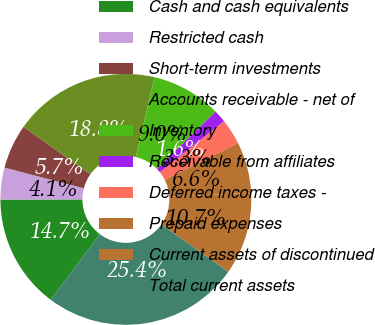Convert chart to OTSL. <chart><loc_0><loc_0><loc_500><loc_500><pie_chart><fcel>Cash and cash equivalents<fcel>Restricted cash<fcel>Short-term investments<fcel>Accounts receivable - net of<fcel>Inventory<fcel>Receivable from affiliates<fcel>Deferred income taxes -<fcel>Prepaid expenses<fcel>Current assets of discontinued<fcel>Total current assets<nl><fcel>14.75%<fcel>4.1%<fcel>5.74%<fcel>18.85%<fcel>9.02%<fcel>1.64%<fcel>3.28%<fcel>6.56%<fcel>10.66%<fcel>25.41%<nl></chart> 